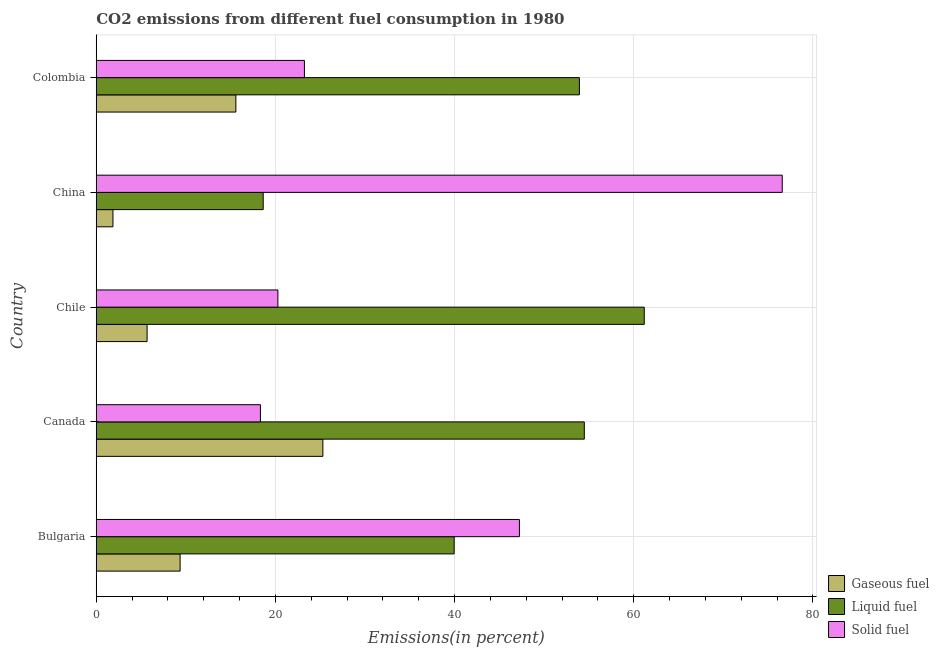How many different coloured bars are there?
Provide a succinct answer. 3. Are the number of bars on each tick of the Y-axis equal?
Provide a short and direct response. Yes. How many bars are there on the 1st tick from the top?
Your answer should be compact. 3. How many bars are there on the 3rd tick from the bottom?
Offer a terse response. 3. What is the label of the 2nd group of bars from the top?
Keep it short and to the point. China. What is the percentage of liquid fuel emission in Colombia?
Make the answer very short. 53.94. Across all countries, what is the maximum percentage of solid fuel emission?
Your answer should be compact. 76.58. Across all countries, what is the minimum percentage of liquid fuel emission?
Offer a very short reply. 18.64. What is the total percentage of solid fuel emission in the graph?
Provide a short and direct response. 185.66. What is the difference between the percentage of liquid fuel emission in Bulgaria and that in Canada?
Provide a succinct answer. -14.53. What is the difference between the percentage of liquid fuel emission in Bulgaria and the percentage of gaseous fuel emission in Chile?
Your response must be concise. 34.28. What is the average percentage of liquid fuel emission per country?
Keep it short and to the point. 45.64. What is the difference between the percentage of liquid fuel emission and percentage of gaseous fuel emission in Colombia?
Provide a short and direct response. 38.35. What is the ratio of the percentage of gaseous fuel emission in Bulgaria to that in China?
Keep it short and to the point. 5.02. Is the difference between the percentage of gaseous fuel emission in Bulgaria and China greater than the difference between the percentage of liquid fuel emission in Bulgaria and China?
Ensure brevity in your answer.  No. What is the difference between the highest and the second highest percentage of solid fuel emission?
Your response must be concise. 29.34. What is the difference between the highest and the lowest percentage of solid fuel emission?
Provide a succinct answer. 58.25. Is the sum of the percentage of liquid fuel emission in Bulgaria and Colombia greater than the maximum percentage of solid fuel emission across all countries?
Provide a succinct answer. Yes. What does the 1st bar from the top in Bulgaria represents?
Your answer should be very brief. Solid fuel. What does the 2nd bar from the bottom in Bulgaria represents?
Offer a very short reply. Liquid fuel. Are all the bars in the graph horizontal?
Provide a succinct answer. Yes. Are the values on the major ticks of X-axis written in scientific E-notation?
Offer a very short reply. No. Does the graph contain any zero values?
Provide a short and direct response. No. Does the graph contain grids?
Offer a very short reply. Yes. How many legend labels are there?
Make the answer very short. 3. What is the title of the graph?
Give a very brief answer. CO2 emissions from different fuel consumption in 1980. What is the label or title of the X-axis?
Your response must be concise. Emissions(in percent). What is the label or title of the Y-axis?
Your answer should be compact. Country. What is the Emissions(in percent) in Gaseous fuel in Bulgaria?
Your answer should be compact. 9.36. What is the Emissions(in percent) of Liquid fuel in Bulgaria?
Your answer should be very brief. 39.96. What is the Emissions(in percent) of Solid fuel in Bulgaria?
Your response must be concise. 47.24. What is the Emissions(in percent) in Gaseous fuel in Canada?
Offer a terse response. 25.3. What is the Emissions(in percent) in Liquid fuel in Canada?
Make the answer very short. 54.48. What is the Emissions(in percent) of Solid fuel in Canada?
Your answer should be very brief. 18.33. What is the Emissions(in percent) of Gaseous fuel in Chile?
Your response must be concise. 5.67. What is the Emissions(in percent) of Liquid fuel in Chile?
Your answer should be very brief. 61.18. What is the Emissions(in percent) of Solid fuel in Chile?
Ensure brevity in your answer.  20.28. What is the Emissions(in percent) in Gaseous fuel in China?
Provide a succinct answer. 1.86. What is the Emissions(in percent) in Liquid fuel in China?
Your answer should be compact. 18.64. What is the Emissions(in percent) of Solid fuel in China?
Provide a short and direct response. 76.58. What is the Emissions(in percent) in Gaseous fuel in Colombia?
Offer a very short reply. 15.58. What is the Emissions(in percent) in Liquid fuel in Colombia?
Your response must be concise. 53.94. What is the Emissions(in percent) of Solid fuel in Colombia?
Provide a short and direct response. 23.24. Across all countries, what is the maximum Emissions(in percent) of Gaseous fuel?
Offer a terse response. 25.3. Across all countries, what is the maximum Emissions(in percent) in Liquid fuel?
Give a very brief answer. 61.18. Across all countries, what is the maximum Emissions(in percent) of Solid fuel?
Provide a short and direct response. 76.58. Across all countries, what is the minimum Emissions(in percent) of Gaseous fuel?
Provide a short and direct response. 1.86. Across all countries, what is the minimum Emissions(in percent) of Liquid fuel?
Provide a short and direct response. 18.64. Across all countries, what is the minimum Emissions(in percent) of Solid fuel?
Your answer should be very brief. 18.33. What is the total Emissions(in percent) of Gaseous fuel in the graph?
Your response must be concise. 57.78. What is the total Emissions(in percent) in Liquid fuel in the graph?
Your response must be concise. 228.19. What is the total Emissions(in percent) in Solid fuel in the graph?
Keep it short and to the point. 185.66. What is the difference between the Emissions(in percent) in Gaseous fuel in Bulgaria and that in Canada?
Your response must be concise. -15.94. What is the difference between the Emissions(in percent) of Liquid fuel in Bulgaria and that in Canada?
Your answer should be very brief. -14.53. What is the difference between the Emissions(in percent) of Solid fuel in Bulgaria and that in Canada?
Your answer should be compact. 28.91. What is the difference between the Emissions(in percent) in Gaseous fuel in Bulgaria and that in Chile?
Offer a very short reply. 3.69. What is the difference between the Emissions(in percent) in Liquid fuel in Bulgaria and that in Chile?
Your answer should be compact. -21.22. What is the difference between the Emissions(in percent) in Solid fuel in Bulgaria and that in Chile?
Your response must be concise. 26.96. What is the difference between the Emissions(in percent) of Gaseous fuel in Bulgaria and that in China?
Provide a succinct answer. 7.5. What is the difference between the Emissions(in percent) of Liquid fuel in Bulgaria and that in China?
Ensure brevity in your answer.  21.32. What is the difference between the Emissions(in percent) in Solid fuel in Bulgaria and that in China?
Provide a short and direct response. -29.34. What is the difference between the Emissions(in percent) in Gaseous fuel in Bulgaria and that in Colombia?
Keep it short and to the point. -6.22. What is the difference between the Emissions(in percent) in Liquid fuel in Bulgaria and that in Colombia?
Your answer should be very brief. -13.98. What is the difference between the Emissions(in percent) of Solid fuel in Bulgaria and that in Colombia?
Your response must be concise. 24. What is the difference between the Emissions(in percent) in Gaseous fuel in Canada and that in Chile?
Your response must be concise. 19.62. What is the difference between the Emissions(in percent) in Liquid fuel in Canada and that in Chile?
Your answer should be very brief. -6.69. What is the difference between the Emissions(in percent) of Solid fuel in Canada and that in Chile?
Offer a very short reply. -1.95. What is the difference between the Emissions(in percent) of Gaseous fuel in Canada and that in China?
Offer a terse response. 23.44. What is the difference between the Emissions(in percent) of Liquid fuel in Canada and that in China?
Provide a succinct answer. 35.85. What is the difference between the Emissions(in percent) in Solid fuel in Canada and that in China?
Make the answer very short. -58.25. What is the difference between the Emissions(in percent) of Gaseous fuel in Canada and that in Colombia?
Offer a very short reply. 9.72. What is the difference between the Emissions(in percent) of Liquid fuel in Canada and that in Colombia?
Give a very brief answer. 0.55. What is the difference between the Emissions(in percent) in Solid fuel in Canada and that in Colombia?
Offer a very short reply. -4.91. What is the difference between the Emissions(in percent) of Gaseous fuel in Chile and that in China?
Your answer should be very brief. 3.81. What is the difference between the Emissions(in percent) in Liquid fuel in Chile and that in China?
Your answer should be very brief. 42.54. What is the difference between the Emissions(in percent) of Solid fuel in Chile and that in China?
Provide a succinct answer. -56.3. What is the difference between the Emissions(in percent) of Gaseous fuel in Chile and that in Colombia?
Provide a short and direct response. -9.91. What is the difference between the Emissions(in percent) in Liquid fuel in Chile and that in Colombia?
Your response must be concise. 7.24. What is the difference between the Emissions(in percent) of Solid fuel in Chile and that in Colombia?
Make the answer very short. -2.96. What is the difference between the Emissions(in percent) in Gaseous fuel in China and that in Colombia?
Your answer should be compact. -13.72. What is the difference between the Emissions(in percent) of Liquid fuel in China and that in Colombia?
Offer a terse response. -35.3. What is the difference between the Emissions(in percent) in Solid fuel in China and that in Colombia?
Your response must be concise. 53.34. What is the difference between the Emissions(in percent) in Gaseous fuel in Bulgaria and the Emissions(in percent) in Liquid fuel in Canada?
Provide a succinct answer. -45.12. What is the difference between the Emissions(in percent) of Gaseous fuel in Bulgaria and the Emissions(in percent) of Solid fuel in Canada?
Your answer should be compact. -8.97. What is the difference between the Emissions(in percent) in Liquid fuel in Bulgaria and the Emissions(in percent) in Solid fuel in Canada?
Make the answer very short. 21.63. What is the difference between the Emissions(in percent) in Gaseous fuel in Bulgaria and the Emissions(in percent) in Liquid fuel in Chile?
Give a very brief answer. -51.81. What is the difference between the Emissions(in percent) of Gaseous fuel in Bulgaria and the Emissions(in percent) of Solid fuel in Chile?
Provide a short and direct response. -10.92. What is the difference between the Emissions(in percent) in Liquid fuel in Bulgaria and the Emissions(in percent) in Solid fuel in Chile?
Provide a short and direct response. 19.68. What is the difference between the Emissions(in percent) of Gaseous fuel in Bulgaria and the Emissions(in percent) of Liquid fuel in China?
Provide a short and direct response. -9.28. What is the difference between the Emissions(in percent) of Gaseous fuel in Bulgaria and the Emissions(in percent) of Solid fuel in China?
Offer a very short reply. -67.22. What is the difference between the Emissions(in percent) of Liquid fuel in Bulgaria and the Emissions(in percent) of Solid fuel in China?
Keep it short and to the point. -36.62. What is the difference between the Emissions(in percent) of Gaseous fuel in Bulgaria and the Emissions(in percent) of Liquid fuel in Colombia?
Provide a short and direct response. -44.57. What is the difference between the Emissions(in percent) of Gaseous fuel in Bulgaria and the Emissions(in percent) of Solid fuel in Colombia?
Keep it short and to the point. -13.88. What is the difference between the Emissions(in percent) of Liquid fuel in Bulgaria and the Emissions(in percent) of Solid fuel in Colombia?
Offer a very short reply. 16.72. What is the difference between the Emissions(in percent) in Gaseous fuel in Canada and the Emissions(in percent) in Liquid fuel in Chile?
Your response must be concise. -35.88. What is the difference between the Emissions(in percent) in Gaseous fuel in Canada and the Emissions(in percent) in Solid fuel in Chile?
Offer a terse response. 5.02. What is the difference between the Emissions(in percent) of Liquid fuel in Canada and the Emissions(in percent) of Solid fuel in Chile?
Keep it short and to the point. 34.21. What is the difference between the Emissions(in percent) in Gaseous fuel in Canada and the Emissions(in percent) in Liquid fuel in China?
Make the answer very short. 6.66. What is the difference between the Emissions(in percent) in Gaseous fuel in Canada and the Emissions(in percent) in Solid fuel in China?
Make the answer very short. -51.28. What is the difference between the Emissions(in percent) in Liquid fuel in Canada and the Emissions(in percent) in Solid fuel in China?
Your answer should be very brief. -22.1. What is the difference between the Emissions(in percent) in Gaseous fuel in Canada and the Emissions(in percent) in Liquid fuel in Colombia?
Offer a terse response. -28.64. What is the difference between the Emissions(in percent) of Gaseous fuel in Canada and the Emissions(in percent) of Solid fuel in Colombia?
Your answer should be compact. 2.06. What is the difference between the Emissions(in percent) of Liquid fuel in Canada and the Emissions(in percent) of Solid fuel in Colombia?
Provide a succinct answer. 31.25. What is the difference between the Emissions(in percent) in Gaseous fuel in Chile and the Emissions(in percent) in Liquid fuel in China?
Your answer should be compact. -12.96. What is the difference between the Emissions(in percent) in Gaseous fuel in Chile and the Emissions(in percent) in Solid fuel in China?
Your answer should be compact. -70.91. What is the difference between the Emissions(in percent) of Liquid fuel in Chile and the Emissions(in percent) of Solid fuel in China?
Offer a terse response. -15.4. What is the difference between the Emissions(in percent) of Gaseous fuel in Chile and the Emissions(in percent) of Liquid fuel in Colombia?
Provide a short and direct response. -48.26. What is the difference between the Emissions(in percent) in Gaseous fuel in Chile and the Emissions(in percent) in Solid fuel in Colombia?
Your response must be concise. -17.56. What is the difference between the Emissions(in percent) of Liquid fuel in Chile and the Emissions(in percent) of Solid fuel in Colombia?
Keep it short and to the point. 37.94. What is the difference between the Emissions(in percent) of Gaseous fuel in China and the Emissions(in percent) of Liquid fuel in Colombia?
Keep it short and to the point. -52.07. What is the difference between the Emissions(in percent) of Gaseous fuel in China and the Emissions(in percent) of Solid fuel in Colombia?
Make the answer very short. -21.38. What is the difference between the Emissions(in percent) of Liquid fuel in China and the Emissions(in percent) of Solid fuel in Colombia?
Your response must be concise. -4.6. What is the average Emissions(in percent) in Gaseous fuel per country?
Ensure brevity in your answer.  11.56. What is the average Emissions(in percent) in Liquid fuel per country?
Offer a very short reply. 45.64. What is the average Emissions(in percent) in Solid fuel per country?
Keep it short and to the point. 37.13. What is the difference between the Emissions(in percent) of Gaseous fuel and Emissions(in percent) of Liquid fuel in Bulgaria?
Make the answer very short. -30.59. What is the difference between the Emissions(in percent) in Gaseous fuel and Emissions(in percent) in Solid fuel in Bulgaria?
Offer a very short reply. -37.88. What is the difference between the Emissions(in percent) of Liquid fuel and Emissions(in percent) of Solid fuel in Bulgaria?
Offer a terse response. -7.28. What is the difference between the Emissions(in percent) in Gaseous fuel and Emissions(in percent) in Liquid fuel in Canada?
Your answer should be very brief. -29.19. What is the difference between the Emissions(in percent) in Gaseous fuel and Emissions(in percent) in Solid fuel in Canada?
Provide a succinct answer. 6.97. What is the difference between the Emissions(in percent) in Liquid fuel and Emissions(in percent) in Solid fuel in Canada?
Offer a terse response. 36.16. What is the difference between the Emissions(in percent) of Gaseous fuel and Emissions(in percent) of Liquid fuel in Chile?
Provide a succinct answer. -55.5. What is the difference between the Emissions(in percent) in Gaseous fuel and Emissions(in percent) in Solid fuel in Chile?
Keep it short and to the point. -14.6. What is the difference between the Emissions(in percent) in Liquid fuel and Emissions(in percent) in Solid fuel in Chile?
Your answer should be very brief. 40.9. What is the difference between the Emissions(in percent) in Gaseous fuel and Emissions(in percent) in Liquid fuel in China?
Ensure brevity in your answer.  -16.77. What is the difference between the Emissions(in percent) of Gaseous fuel and Emissions(in percent) of Solid fuel in China?
Ensure brevity in your answer.  -74.72. What is the difference between the Emissions(in percent) of Liquid fuel and Emissions(in percent) of Solid fuel in China?
Offer a terse response. -57.94. What is the difference between the Emissions(in percent) of Gaseous fuel and Emissions(in percent) of Liquid fuel in Colombia?
Ensure brevity in your answer.  -38.35. What is the difference between the Emissions(in percent) of Gaseous fuel and Emissions(in percent) of Solid fuel in Colombia?
Offer a terse response. -7.66. What is the difference between the Emissions(in percent) in Liquid fuel and Emissions(in percent) in Solid fuel in Colombia?
Make the answer very short. 30.7. What is the ratio of the Emissions(in percent) of Gaseous fuel in Bulgaria to that in Canada?
Offer a terse response. 0.37. What is the ratio of the Emissions(in percent) in Liquid fuel in Bulgaria to that in Canada?
Offer a terse response. 0.73. What is the ratio of the Emissions(in percent) of Solid fuel in Bulgaria to that in Canada?
Provide a succinct answer. 2.58. What is the ratio of the Emissions(in percent) in Gaseous fuel in Bulgaria to that in Chile?
Ensure brevity in your answer.  1.65. What is the ratio of the Emissions(in percent) of Liquid fuel in Bulgaria to that in Chile?
Your answer should be very brief. 0.65. What is the ratio of the Emissions(in percent) in Solid fuel in Bulgaria to that in Chile?
Provide a short and direct response. 2.33. What is the ratio of the Emissions(in percent) of Gaseous fuel in Bulgaria to that in China?
Provide a succinct answer. 5.02. What is the ratio of the Emissions(in percent) in Liquid fuel in Bulgaria to that in China?
Provide a succinct answer. 2.14. What is the ratio of the Emissions(in percent) in Solid fuel in Bulgaria to that in China?
Your response must be concise. 0.62. What is the ratio of the Emissions(in percent) of Gaseous fuel in Bulgaria to that in Colombia?
Offer a very short reply. 0.6. What is the ratio of the Emissions(in percent) of Liquid fuel in Bulgaria to that in Colombia?
Keep it short and to the point. 0.74. What is the ratio of the Emissions(in percent) of Solid fuel in Bulgaria to that in Colombia?
Make the answer very short. 2.03. What is the ratio of the Emissions(in percent) in Gaseous fuel in Canada to that in Chile?
Give a very brief answer. 4.46. What is the ratio of the Emissions(in percent) in Liquid fuel in Canada to that in Chile?
Your response must be concise. 0.89. What is the ratio of the Emissions(in percent) of Solid fuel in Canada to that in Chile?
Offer a terse response. 0.9. What is the ratio of the Emissions(in percent) of Gaseous fuel in Canada to that in China?
Offer a terse response. 13.58. What is the ratio of the Emissions(in percent) of Liquid fuel in Canada to that in China?
Your answer should be compact. 2.92. What is the ratio of the Emissions(in percent) in Solid fuel in Canada to that in China?
Provide a short and direct response. 0.24. What is the ratio of the Emissions(in percent) in Gaseous fuel in Canada to that in Colombia?
Make the answer very short. 1.62. What is the ratio of the Emissions(in percent) in Liquid fuel in Canada to that in Colombia?
Ensure brevity in your answer.  1.01. What is the ratio of the Emissions(in percent) of Solid fuel in Canada to that in Colombia?
Ensure brevity in your answer.  0.79. What is the ratio of the Emissions(in percent) in Gaseous fuel in Chile to that in China?
Offer a terse response. 3.05. What is the ratio of the Emissions(in percent) in Liquid fuel in Chile to that in China?
Offer a terse response. 3.28. What is the ratio of the Emissions(in percent) of Solid fuel in Chile to that in China?
Make the answer very short. 0.26. What is the ratio of the Emissions(in percent) of Gaseous fuel in Chile to that in Colombia?
Keep it short and to the point. 0.36. What is the ratio of the Emissions(in percent) in Liquid fuel in Chile to that in Colombia?
Your answer should be very brief. 1.13. What is the ratio of the Emissions(in percent) in Solid fuel in Chile to that in Colombia?
Ensure brevity in your answer.  0.87. What is the ratio of the Emissions(in percent) of Gaseous fuel in China to that in Colombia?
Offer a very short reply. 0.12. What is the ratio of the Emissions(in percent) in Liquid fuel in China to that in Colombia?
Your response must be concise. 0.35. What is the ratio of the Emissions(in percent) of Solid fuel in China to that in Colombia?
Provide a short and direct response. 3.3. What is the difference between the highest and the second highest Emissions(in percent) in Gaseous fuel?
Ensure brevity in your answer.  9.72. What is the difference between the highest and the second highest Emissions(in percent) of Liquid fuel?
Ensure brevity in your answer.  6.69. What is the difference between the highest and the second highest Emissions(in percent) of Solid fuel?
Your answer should be very brief. 29.34. What is the difference between the highest and the lowest Emissions(in percent) of Gaseous fuel?
Your response must be concise. 23.44. What is the difference between the highest and the lowest Emissions(in percent) in Liquid fuel?
Make the answer very short. 42.54. What is the difference between the highest and the lowest Emissions(in percent) in Solid fuel?
Offer a very short reply. 58.25. 